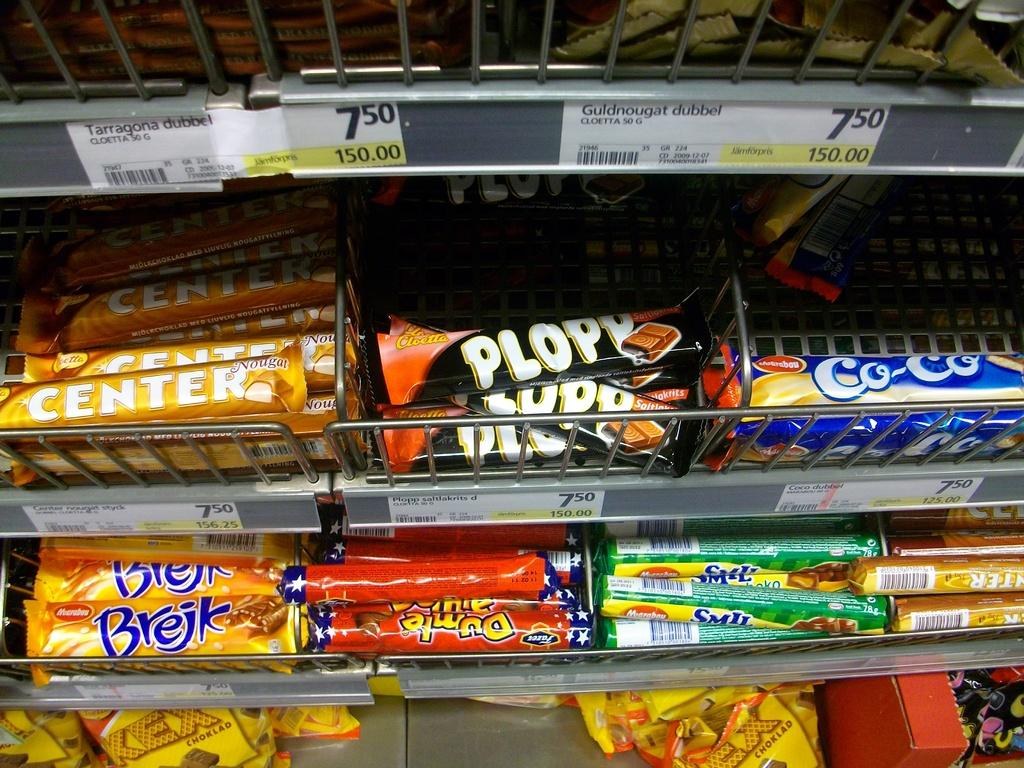<image>
Share a concise interpretation of the image provided. Rows of candy bars including Plopy and Co-Co. 